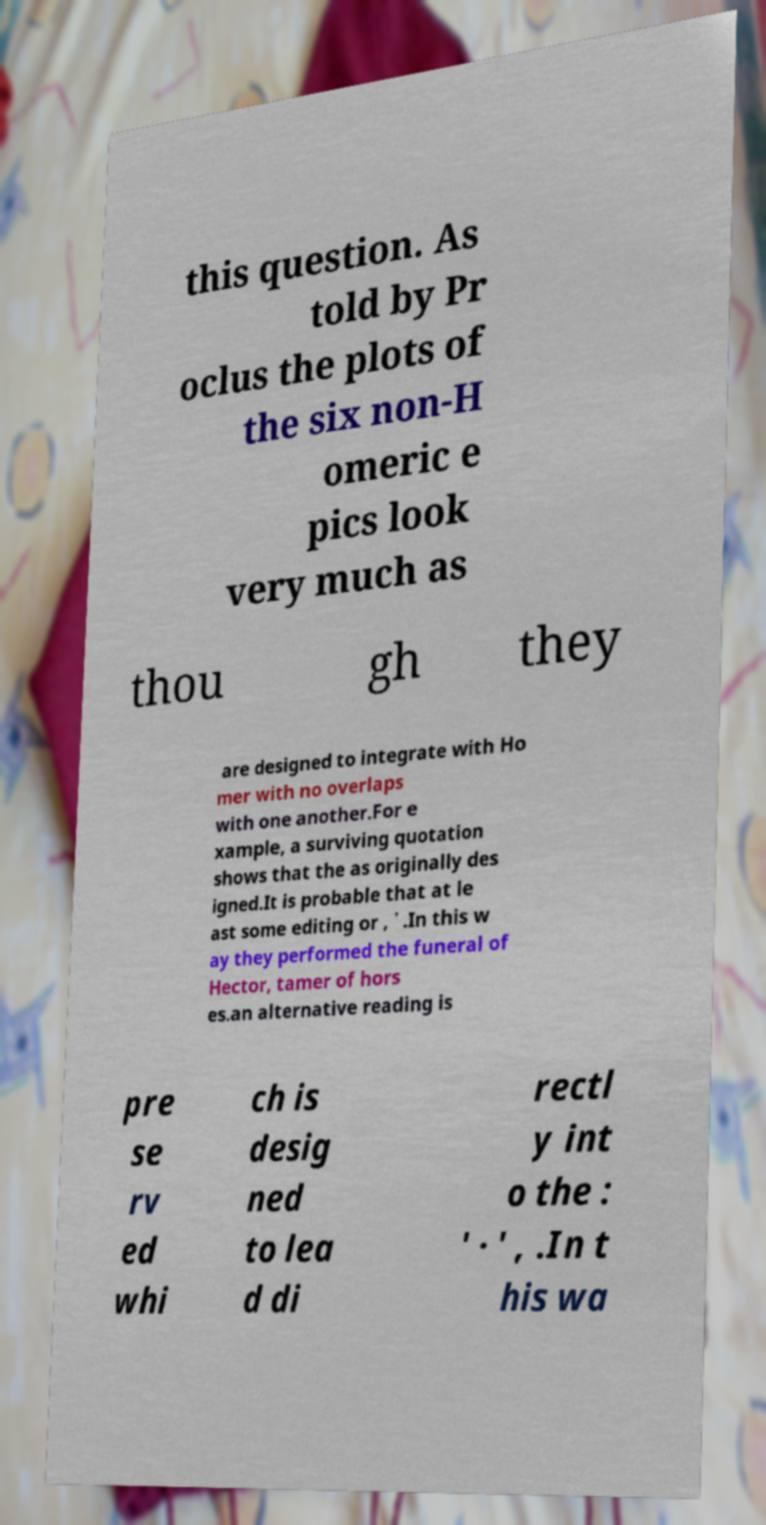There's text embedded in this image that I need extracted. Can you transcribe it verbatim? this question. As told by Pr oclus the plots of the six non-H omeric e pics look very much as thou gh they are designed to integrate with Ho mer with no overlaps with one another.For e xample, a surviving quotation shows that the as originally des igned.It is probable that at le ast some editing or , ᾽ .In this w ay they performed the funeral of Hector, tamer of hors es.an alternative reading is pre se rv ed whi ch is desig ned to lea d di rectl y int o the : ' · ' , .In t his wa 